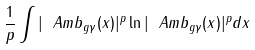<formula> <loc_0><loc_0><loc_500><loc_500>\frac { 1 } { p } \int | \ A m b _ { g \gamma } ( x ) | ^ { p } \ln | \ A m b _ { g \gamma } ( x ) | ^ { p } d x</formula> 